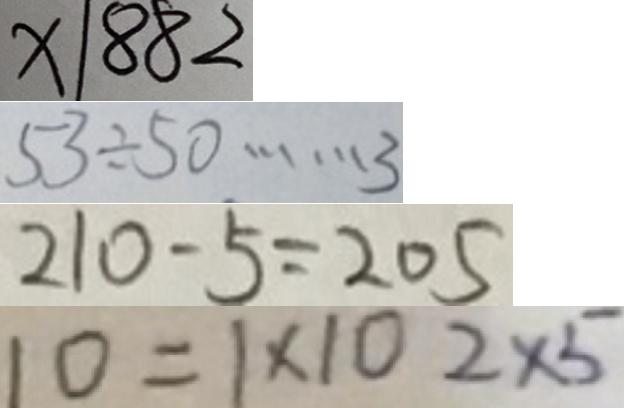Convert formula to latex. <formula><loc_0><loc_0><loc_500><loc_500>x \vert 8 8 2 
 5 3 \div 5 0 \cdots 3 
 2 1 0 - 5 = 2 0 5 
 1 0 = 1 \times 1 0 2 \times 5</formula> 